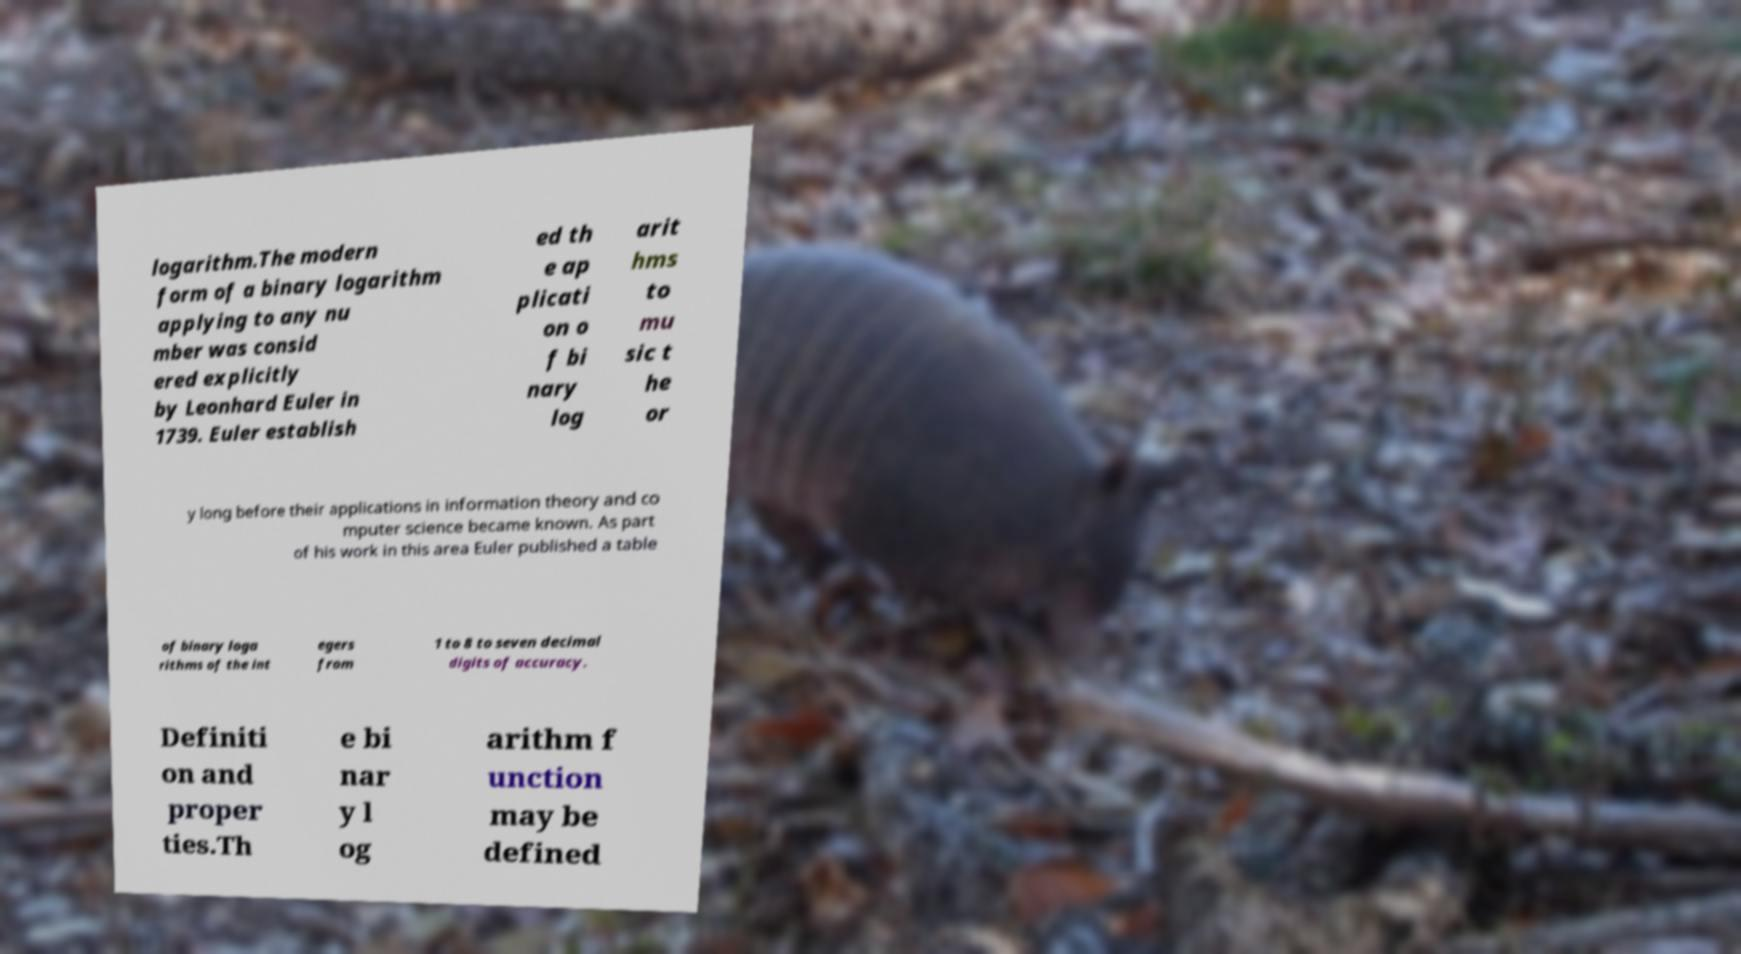There's text embedded in this image that I need extracted. Can you transcribe it verbatim? logarithm.The modern form of a binary logarithm applying to any nu mber was consid ered explicitly by Leonhard Euler in 1739. Euler establish ed th e ap plicati on o f bi nary log arit hms to mu sic t he or y long before their applications in information theory and co mputer science became known. As part of his work in this area Euler published a table of binary loga rithms of the int egers from 1 to 8 to seven decimal digits of accuracy. Definiti on and proper ties.Th e bi nar y l og arithm f unction may be defined 